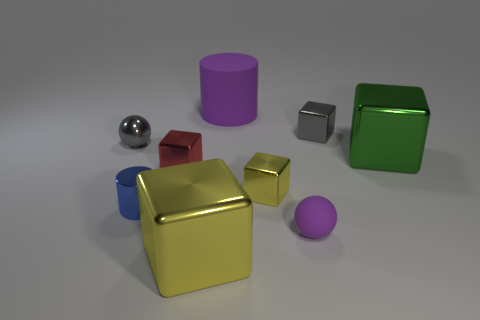Subtract all red blocks. How many blocks are left? 4 Subtract all green cubes. How many cubes are left? 4 Subtract all purple cubes. Subtract all red cylinders. How many cubes are left? 5 Add 1 purple matte cylinders. How many objects exist? 10 Subtract all blocks. How many objects are left? 4 Add 5 shiny cubes. How many shiny cubes are left? 10 Add 2 tiny cyan cylinders. How many tiny cyan cylinders exist? 2 Subtract 0 green balls. How many objects are left? 9 Subtract all tiny matte spheres. Subtract all large purple rubber cylinders. How many objects are left? 7 